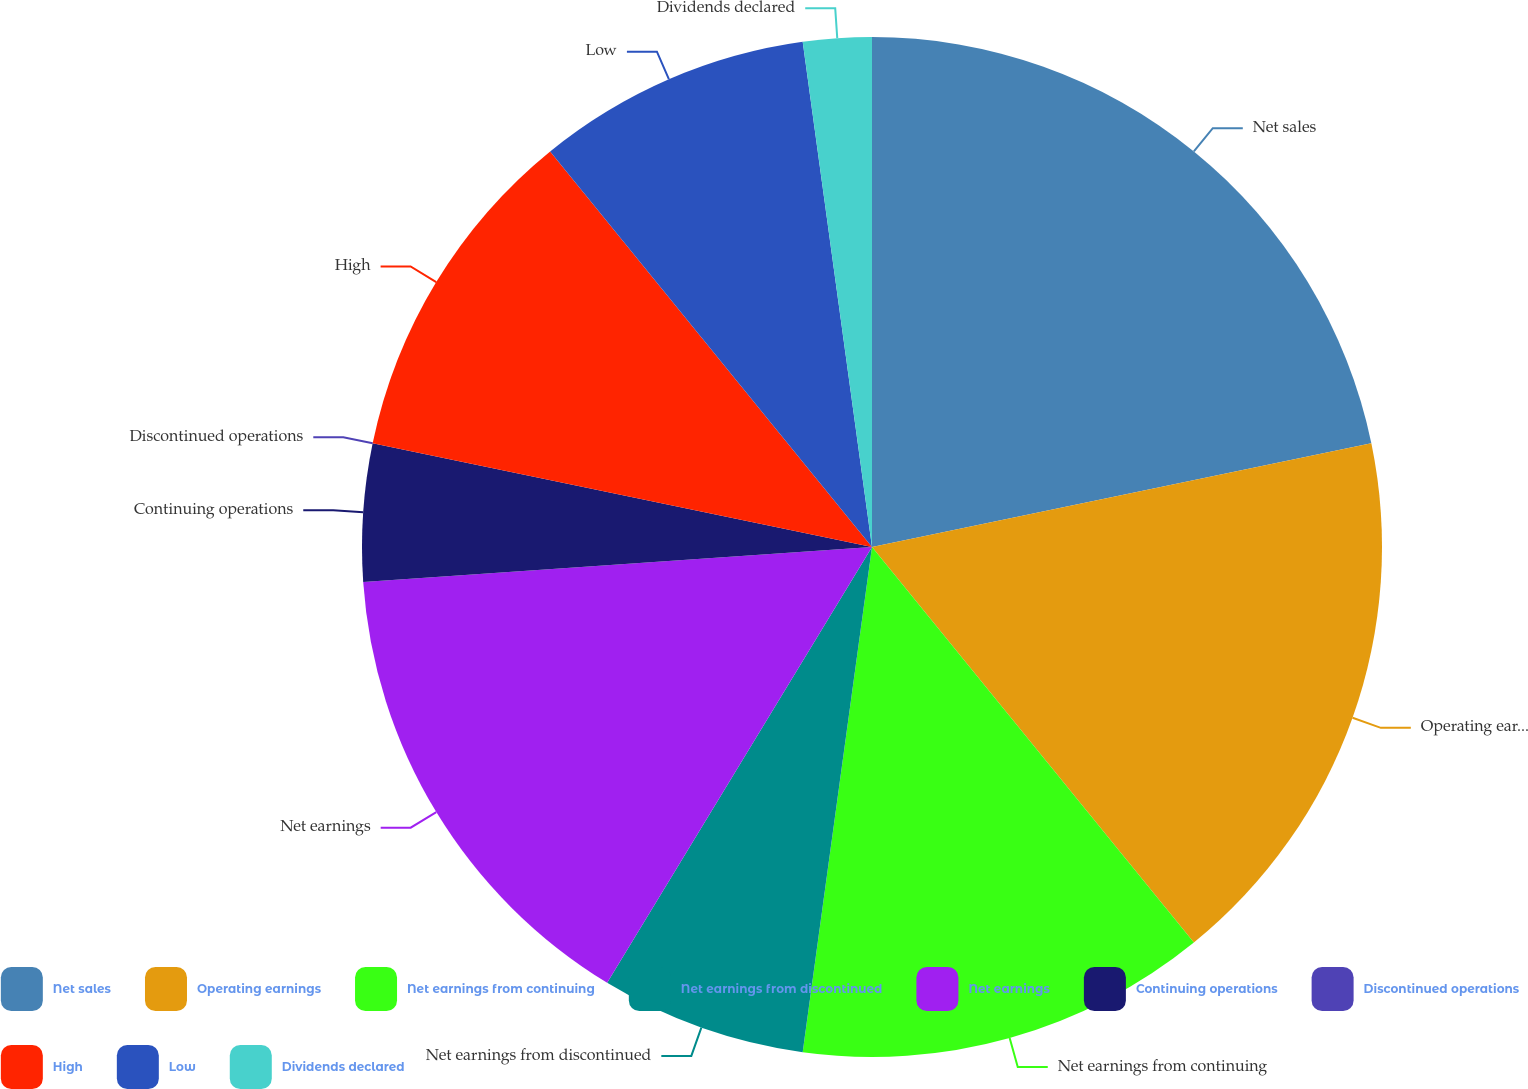<chart> <loc_0><loc_0><loc_500><loc_500><pie_chart><fcel>Net sales<fcel>Operating earnings<fcel>Net earnings from continuing<fcel>Net earnings from discontinued<fcel>Net earnings<fcel>Continuing operations<fcel>Discontinued operations<fcel>High<fcel>Low<fcel>Dividends declared<nl><fcel>21.74%<fcel>17.39%<fcel>13.04%<fcel>6.52%<fcel>15.22%<fcel>4.35%<fcel>0.0%<fcel>10.87%<fcel>8.7%<fcel>2.17%<nl></chart> 